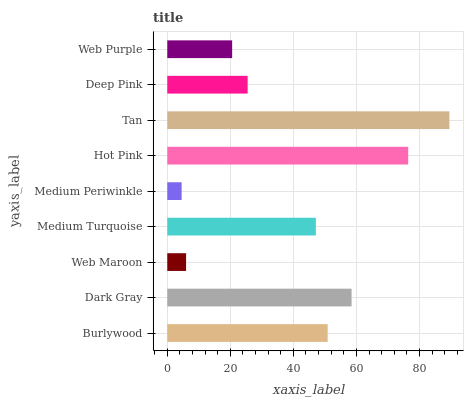Is Medium Periwinkle the minimum?
Answer yes or no. Yes. Is Tan the maximum?
Answer yes or no. Yes. Is Dark Gray the minimum?
Answer yes or no. No. Is Dark Gray the maximum?
Answer yes or no. No. Is Dark Gray greater than Burlywood?
Answer yes or no. Yes. Is Burlywood less than Dark Gray?
Answer yes or no. Yes. Is Burlywood greater than Dark Gray?
Answer yes or no. No. Is Dark Gray less than Burlywood?
Answer yes or no. No. Is Medium Turquoise the high median?
Answer yes or no. Yes. Is Medium Turquoise the low median?
Answer yes or no. Yes. Is Web Purple the high median?
Answer yes or no. No. Is Tan the low median?
Answer yes or no. No. 